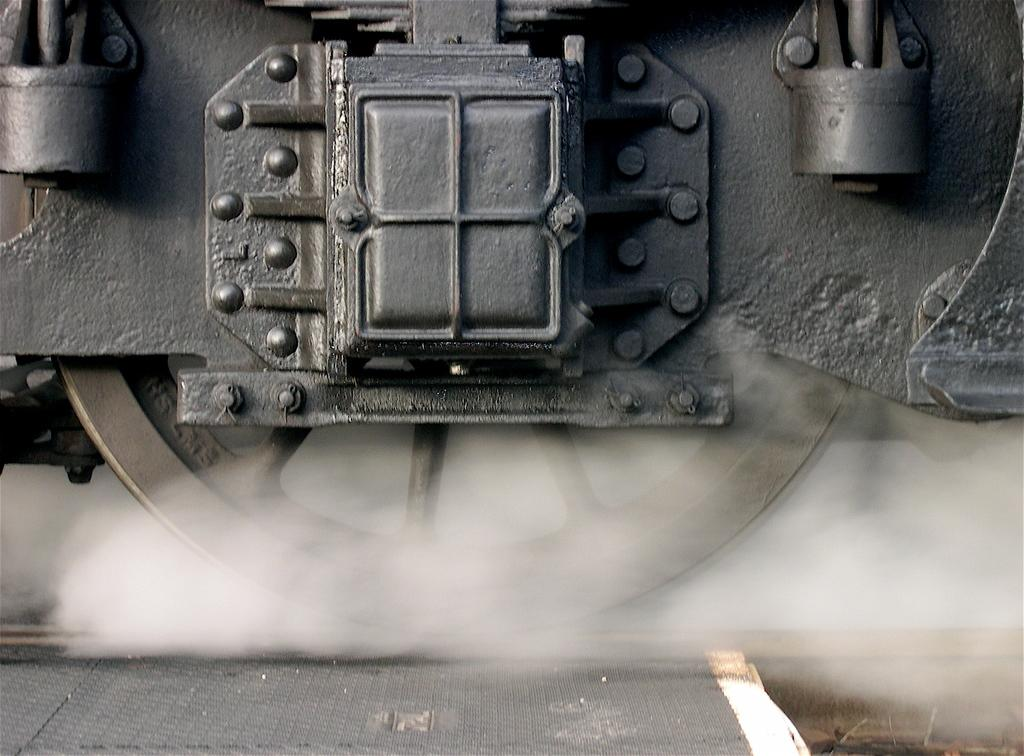What is the main subject of the image? The main subject of the image is a train wheel. What is the train wheel resting on in the image? There is a railway track in the image. What type of angle is being used to celebrate the cub's birthday in the image? There is no angle, cub, or birthday celebration present in the image; it only features a train wheel and a railway track. 